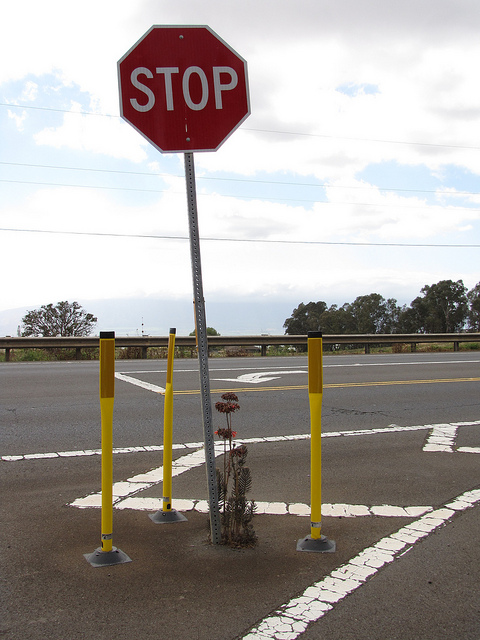Identify the text contained in this image. STOP 